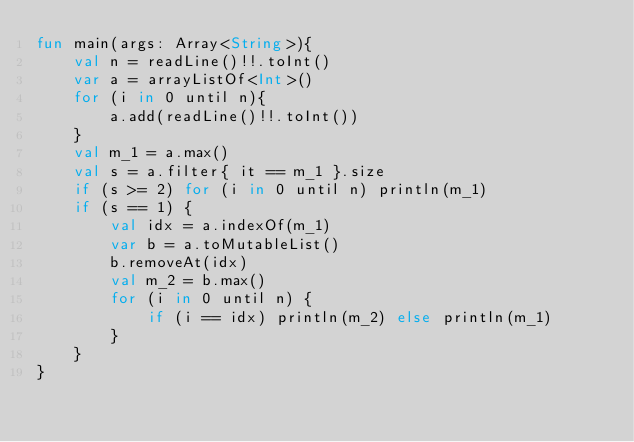<code> <loc_0><loc_0><loc_500><loc_500><_Kotlin_>fun main(args: Array<String>){
    val n = readLine()!!.toInt()
    var a = arrayListOf<Int>()
    for (i in 0 until n){
        a.add(readLine()!!.toInt())
    }
    val m_1 = a.max()
    val s = a.filter{ it == m_1 }.size
    if (s >= 2) for (i in 0 until n) println(m_1)
    if (s == 1) {
        val idx = a.indexOf(m_1)
        var b = a.toMutableList()
        b.removeAt(idx)
        val m_2 = b.max()
        for (i in 0 until n) {
            if (i == idx) println(m_2) else println(m_1)
        }
    }
}
</code> 